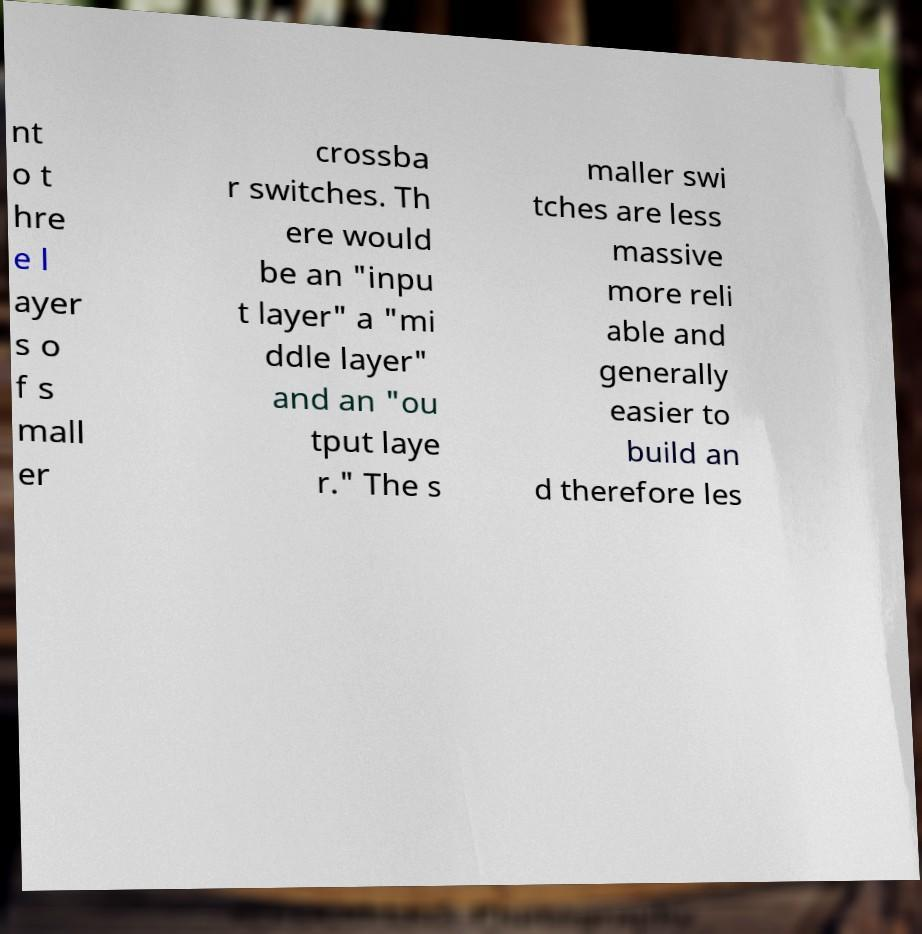Can you accurately transcribe the text from the provided image for me? nt o t hre e l ayer s o f s mall er crossba r switches. Th ere would be an "inpu t layer" a "mi ddle layer" and an "ou tput laye r." The s maller swi tches are less massive more reli able and generally easier to build an d therefore les 